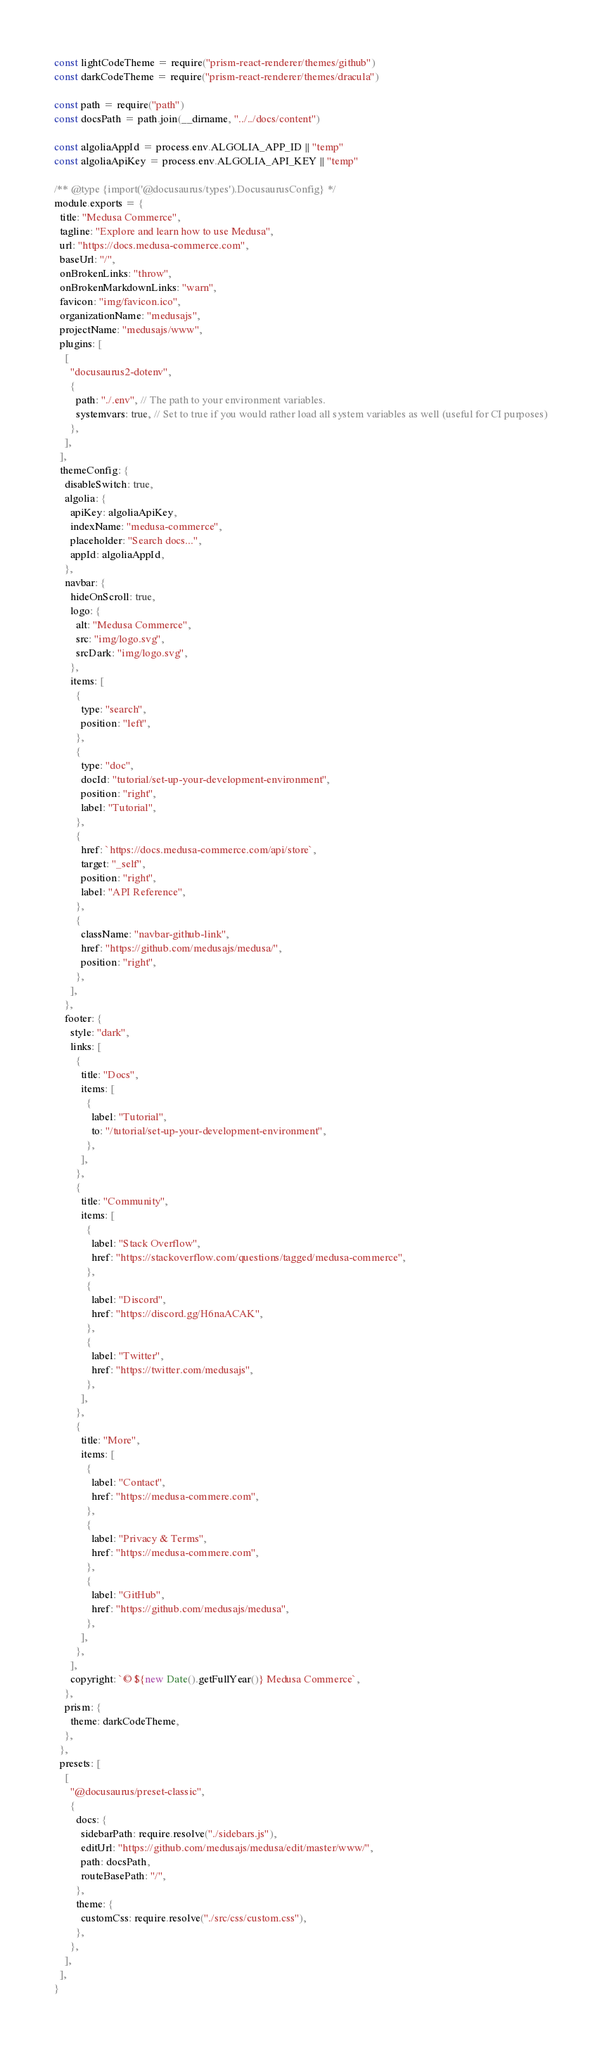<code> <loc_0><loc_0><loc_500><loc_500><_JavaScript_>const lightCodeTheme = require("prism-react-renderer/themes/github")
const darkCodeTheme = require("prism-react-renderer/themes/dracula")

const path = require("path")
const docsPath = path.join(__dirname, "../../docs/content")

const algoliaAppId = process.env.ALGOLIA_APP_ID || "temp"
const algoliaApiKey = process.env.ALGOLIA_API_KEY || "temp"

/** @type {import('@docusaurus/types').DocusaurusConfig} */
module.exports = {
  title: "Medusa Commerce",
  tagline: "Explore and learn how to use Medusa",
  url: "https://docs.medusa-commerce.com",
  baseUrl: "/",
  onBrokenLinks: "throw",
  onBrokenMarkdownLinks: "warn",
  favicon: "img/favicon.ico",
  organizationName: "medusajs",
  projectName: "medusajs/www",
  plugins: [
    [
      "docusaurus2-dotenv",
      {
        path: "./.env", // The path to your environment variables.
        systemvars: true, // Set to true if you would rather load all system variables as well (useful for CI purposes)
      },
    ],
  ],
  themeConfig: {
    disableSwitch: true,
    algolia: {
      apiKey: algoliaApiKey,
      indexName: "medusa-commerce",
      placeholder: "Search docs...",
      appId: algoliaAppId,
    },
    navbar: {
      hideOnScroll: true,
      logo: {
        alt: "Medusa Commerce",
        src: "img/logo.svg",
        srcDark: "img/logo.svg",
      },
      items: [
        {
          type: "search",
          position: "left",
        },
        {
          type: "doc",
          docId: "tutorial/set-up-your-development-environment",
          position: "right",
          label: "Tutorial",
        },
        {
          href: `https://docs.medusa-commerce.com/api/store`,
          target: "_self",
          position: "right",
          label: "API Reference",
        },
        {
          className: "navbar-github-link",
          href: "https://github.com/medusajs/medusa/",
          position: "right",
        },
      ],
    },
    footer: {
      style: "dark",
      links: [
        {
          title: "Docs",
          items: [
            {
              label: "Tutorial",
              to: "/tutorial/set-up-your-development-environment",
            },
          ],
        },
        {
          title: "Community",
          items: [
            {
              label: "Stack Overflow",
              href: "https://stackoverflow.com/questions/tagged/medusa-commerce",
            },
            {
              label: "Discord",
              href: "https://discord.gg/H6naACAK",
            },
            {
              label: "Twitter",
              href: "https://twitter.com/medusajs",
            },
          ],
        },
        {
          title: "More",
          items: [
            {
              label: "Contact",
              href: "https://medusa-commere.com",
            },
            {
              label: "Privacy & Terms",
              href: "https://medusa-commere.com",
            },
            {
              label: "GitHub",
              href: "https://github.com/medusajs/medusa",
            },
          ],
        },
      ],
      copyright: `© ${new Date().getFullYear()} Medusa Commerce`,
    },
    prism: {
      theme: darkCodeTheme,
    },
  },
  presets: [
    [
      "@docusaurus/preset-classic",
      {
        docs: {
          sidebarPath: require.resolve("./sidebars.js"),
          editUrl: "https://github.com/medusajs/medusa/edit/master/www/",
          path: docsPath,
          routeBasePath: "/",
        },
        theme: {
          customCss: require.resolve("./src/css/custom.css"),
        },
      },
    ],
  ],
}
</code> 